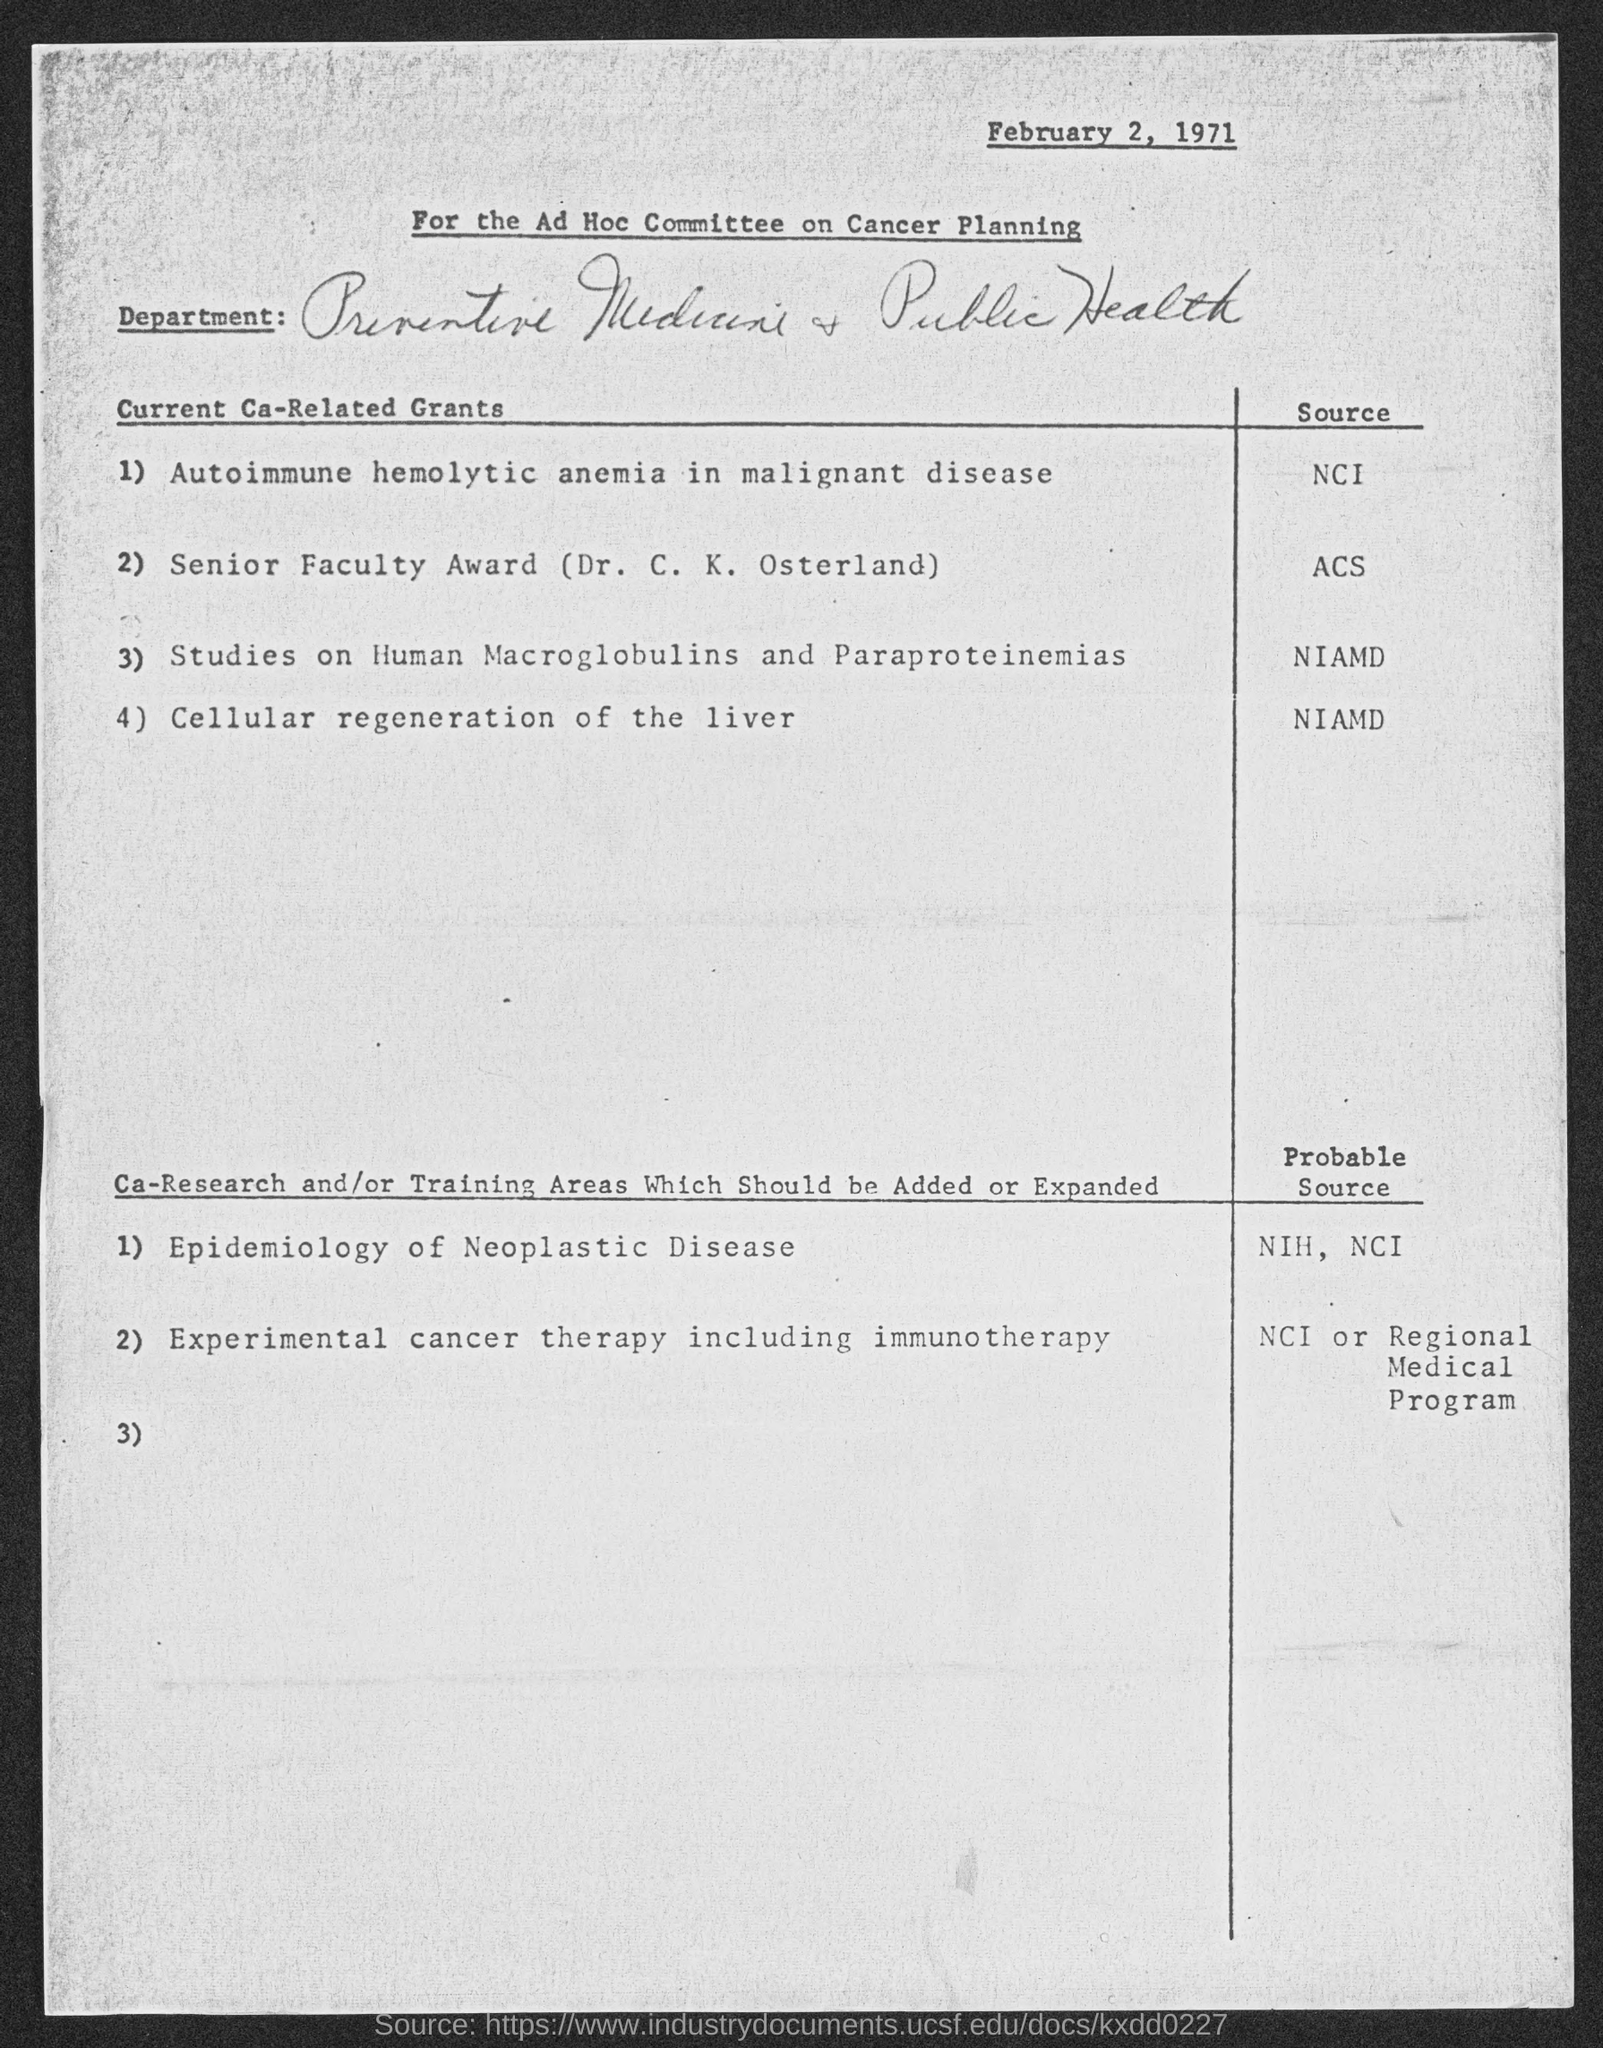Draw attention to some important aspects in this diagram. Autoimmune hemolytic anemia is a type of anemia that occurs when the body's immune system attacks and destroys its own red blood cells. This condition is commonly seen in individuals with malignant diseases, and the National Cancer Institute (NCI) is currently funding a grant related to this topic. The source for information on Studies on Human Macroglobulins and Paraproteinemias is the National Institutes of Allergy and Infectious Diseases (NIAMD). The date at the top of the page is February 2, 1971. 